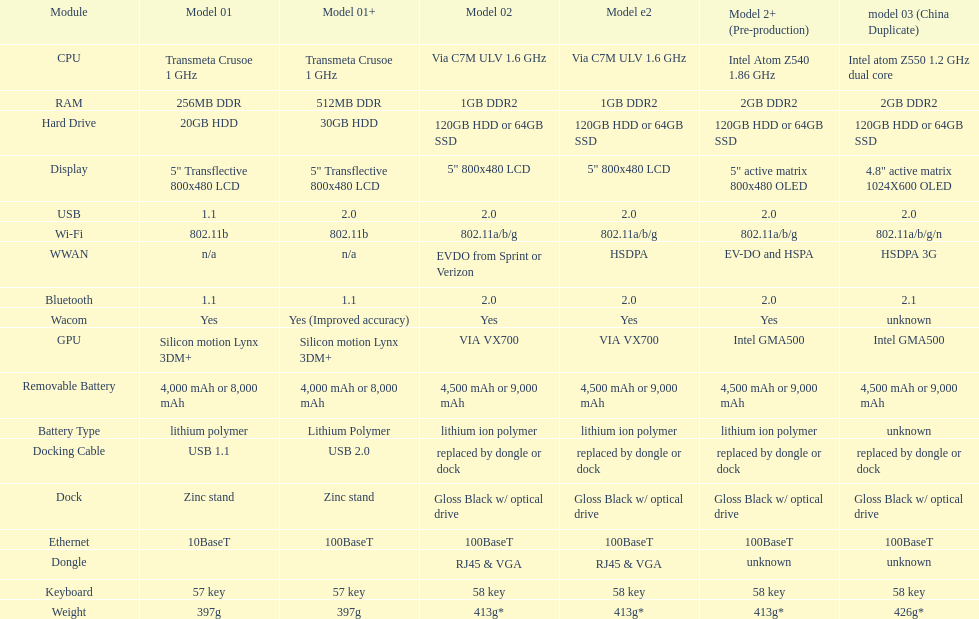How many models use a usb docking cable? 2. 